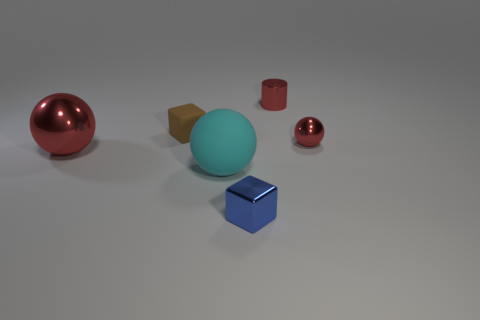Add 2 green blocks. How many objects exist? 8 Subtract all cylinders. How many objects are left? 5 Subtract 1 balls. How many balls are left? 2 Subtract all cyan spheres. Subtract all brown blocks. How many spheres are left? 2 Subtract all blue cylinders. How many blue blocks are left? 1 Subtract all large things. Subtract all red things. How many objects are left? 1 Add 6 small blue metal cubes. How many small blue metal cubes are left? 7 Add 2 small blue things. How many small blue things exist? 3 Subtract all cyan spheres. How many spheres are left? 2 Subtract all big red balls. How many balls are left? 2 